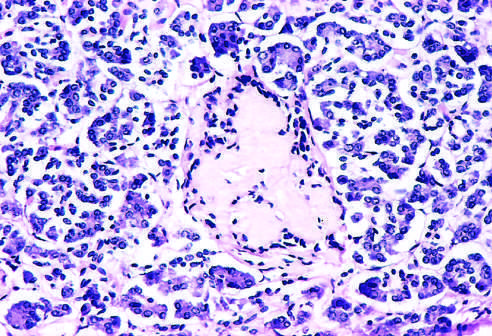what is noted at earlier observations?
Answer the question using a single word or phrase. Islet inflammation 